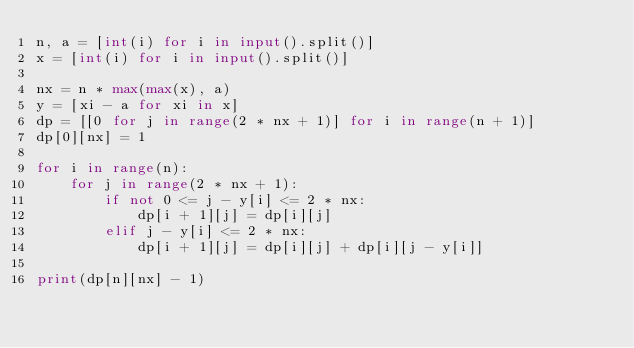<code> <loc_0><loc_0><loc_500><loc_500><_Python_>n, a = [int(i) for i in input().split()]
x = [int(i) for i in input().split()]

nx = n * max(max(x), a)
y = [xi - a for xi in x]
dp = [[0 for j in range(2 * nx + 1)] for i in range(n + 1)]
dp[0][nx] = 1

for i in range(n):
    for j in range(2 * nx + 1):
        if not 0 <= j - y[i] <= 2 * nx:
            dp[i + 1][j] = dp[i][j]
        elif j - y[i] <= 2 * nx:
            dp[i + 1][j] = dp[i][j] + dp[i][j - y[i]]

print(dp[n][nx] - 1)
</code> 